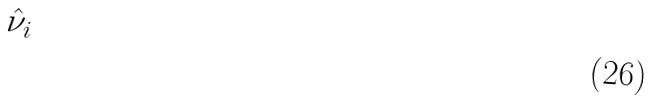Convert formula to latex. <formula><loc_0><loc_0><loc_500><loc_500>\hat { \nu } _ { i }</formula> 